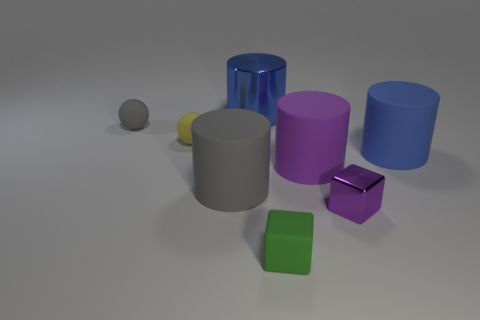Subtract all purple blocks. How many blue cylinders are left? 2 Subtract all purple cylinders. How many cylinders are left? 3 Add 2 big purple rubber cylinders. How many objects exist? 10 Subtract all purple cylinders. How many cylinders are left? 3 Subtract all spheres. How many objects are left? 6 Subtract all cyan cylinders. Subtract all yellow balls. How many cylinders are left? 4 Add 6 tiny metal blocks. How many tiny metal blocks exist? 7 Subtract 0 cyan cubes. How many objects are left? 8 Subtract all big blue rubber things. Subtract all large gray objects. How many objects are left? 6 Add 8 blue cylinders. How many blue cylinders are left? 10 